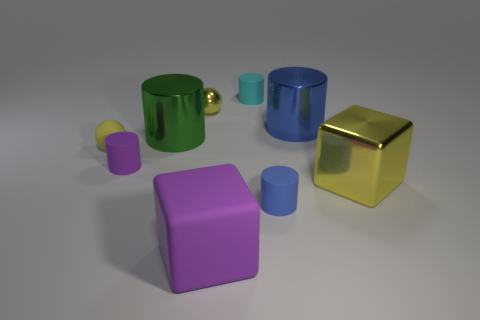What materials seem to be represented by the objects in this image? The objects in the image appear to have different textures suggesting a variety of materials. The yellow sphere looks metallic due to its reflective surface, while the purple and green objects have a matte finish, possibly indicating a plastic or painted metal material. The blue object, also with a reflective surface, could be made of a polished metal or ceramic. 